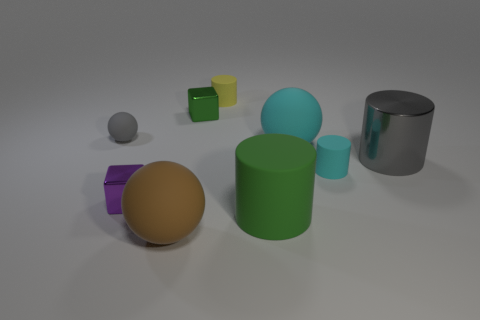Are there more tiny matte cylinders than green cubes?
Your answer should be very brief. Yes. How many small red metallic spheres are there?
Make the answer very short. 0. What shape is the green thing that is to the right of the rubber cylinder behind the shiny thing that is behind the big metal object?
Provide a short and direct response. Cylinder. Is the number of large cylinders behind the purple shiny block less than the number of green shiny things left of the small gray matte sphere?
Provide a short and direct response. No. There is a small metal object that is to the right of the purple block; is its shape the same as the tiny thing behind the green shiny cube?
Make the answer very short. No. What shape is the gray thing that is behind the large cylinder behind the green rubber object?
Give a very brief answer. Sphere. What size is the sphere that is the same color as the shiny cylinder?
Provide a succinct answer. Small. Are there any big gray cylinders that have the same material as the big cyan thing?
Ensure brevity in your answer.  No. What material is the big gray object that is on the right side of the purple shiny block?
Offer a very short reply. Metal. What is the material of the small yellow thing?
Make the answer very short. Rubber. 